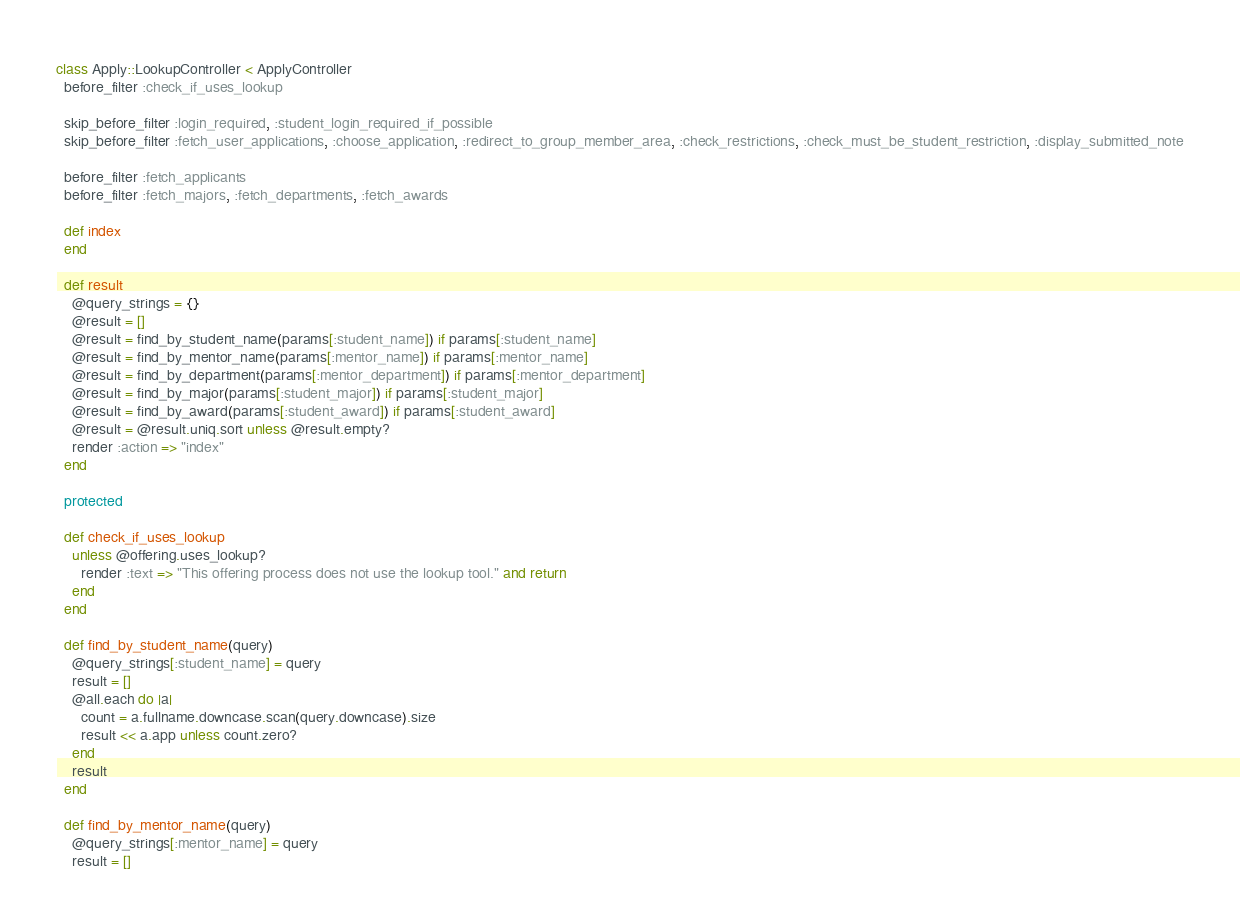Convert code to text. <code><loc_0><loc_0><loc_500><loc_500><_Ruby_>class Apply::LookupController < ApplyController
  before_filter :check_if_uses_lookup
  
  skip_before_filter :login_required, :student_login_required_if_possible
  skip_before_filter :fetch_user_applications, :choose_application, :redirect_to_group_member_area, :check_restrictions, :check_must_be_student_restriction, :display_submitted_note
  
  before_filter :fetch_applicants
  before_filter :fetch_majors, :fetch_departments, :fetch_awards
    
  def index
  end
  
  def result
    @query_strings = {}
    @result = []
    @result = find_by_student_name(params[:student_name]) if params[:student_name]
    @result = find_by_mentor_name(params[:mentor_name]) if params[:mentor_name]
    @result = find_by_department(params[:mentor_department]) if params[:mentor_department]
    @result = find_by_major(params[:student_major]) if params[:student_major]
    @result = find_by_award(params[:student_award]) if params[:student_award]
    @result = @result.uniq.sort unless @result.empty?
    render :action => "index"
  end
  
  protected
  
  def check_if_uses_lookup
    unless @offering.uses_lookup?
      render :text => "This offering process does not use the lookup tool." and return
    end
  end
  
  def find_by_student_name(query)
    @query_strings[:student_name] = query
    result = []
    @all.each do |a|
      count = a.fullname.downcase.scan(query.downcase).size
      result << a.app unless count.zero?
    end
    result
  end

  def find_by_mentor_name(query)
    @query_strings[:mentor_name] = query
    result = []</code> 